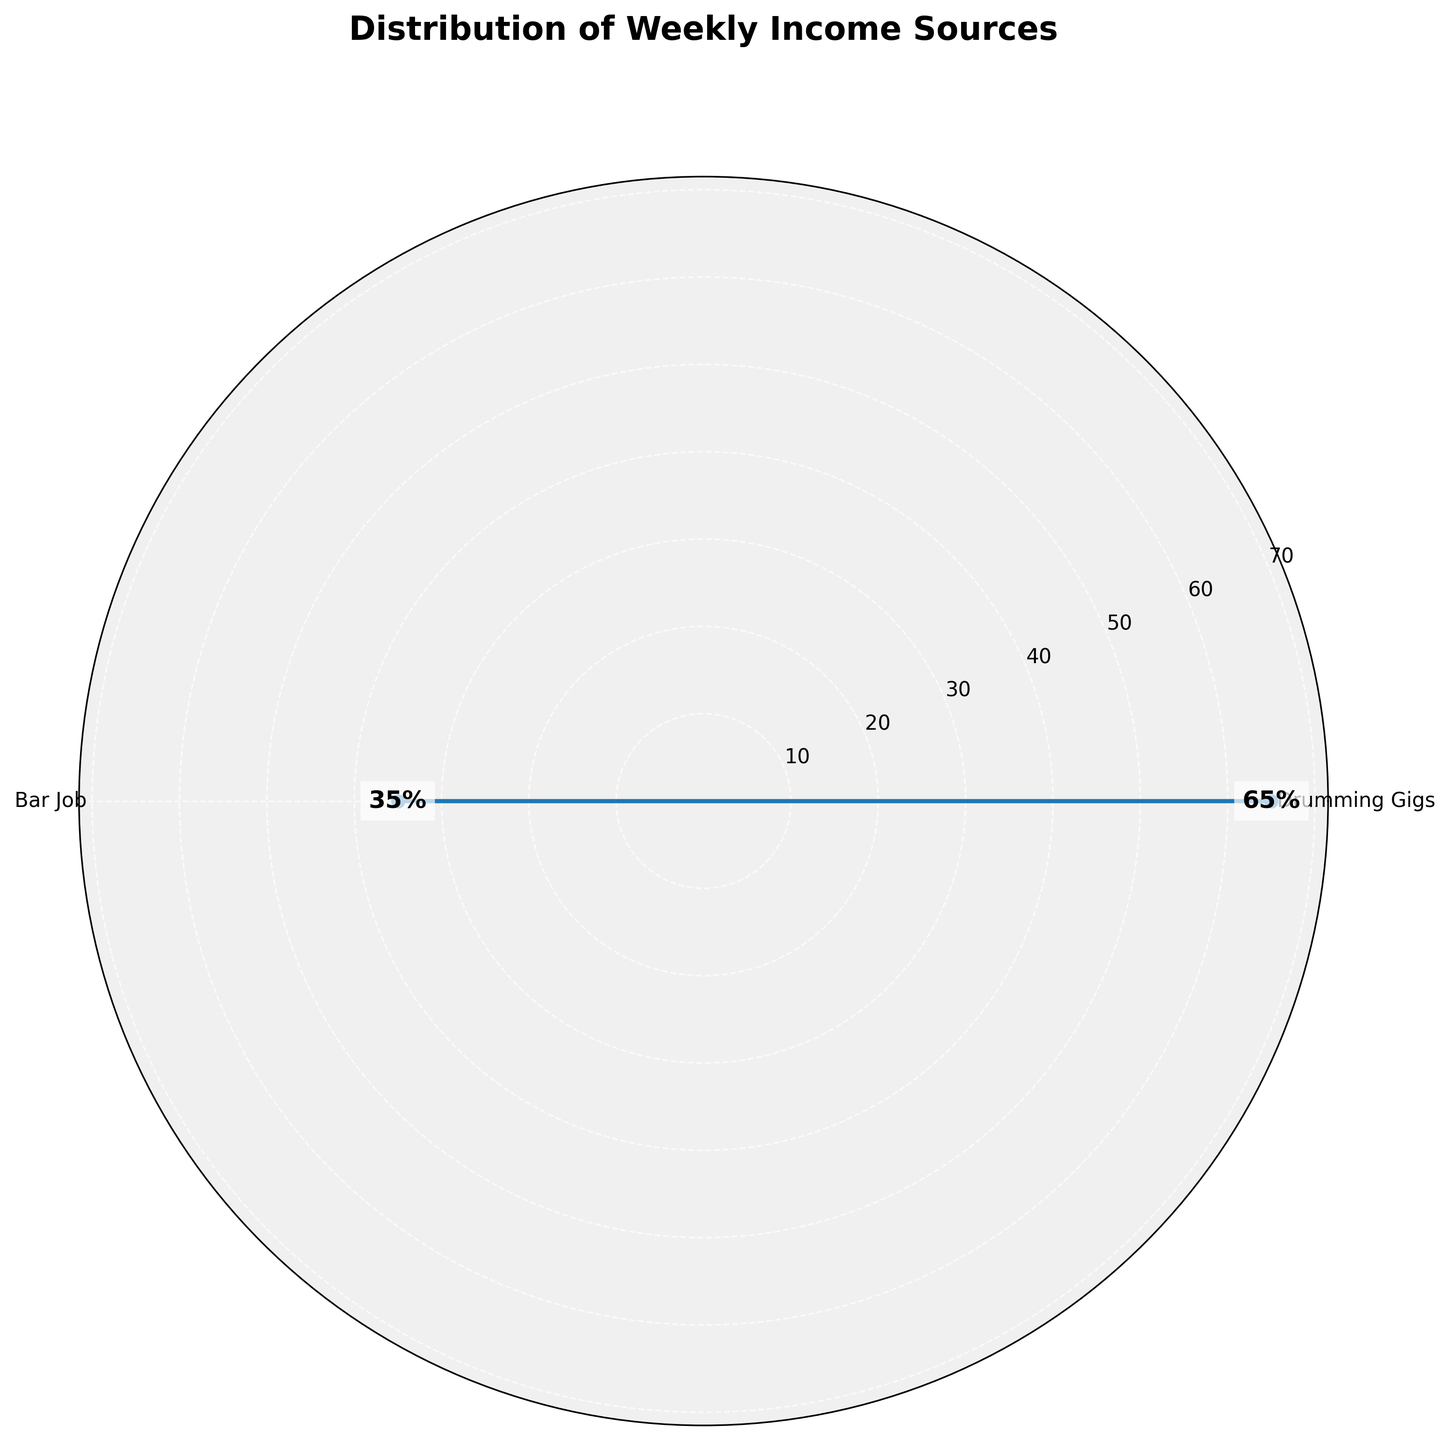What's the title of the figure? The title is located at the top of the figure. It summarizes the main topic of the chart.
Answer: Distribution of Weekly Income Sources How many income sources are represented in the figure? By counting the labeled ticks around the circular axis, we can see there are two categories labeled.
Answer: 2 What percentage does the bar job contribute to the weekly income? Examine the text labels indicating percentages near each corresponding data point on the chart.
Answer: 35% What is the difference in percentage between drumming gigs and the bar job? Subtract the percentage of the bar job (35%) from the percentage of drumming gigs (65%).
Answer: 30% Which income source has a higher percentage? Compare the percentages labeled near each data point. The category with the higher percentage has more contribution.
Answer: Drumming Gigs How are the values represented on the radial axis? Each radial line extending out from the center of the chart corresponds to a specific percentage value. The values are marked appropriately along each radial.
Answer: Percentages What is the visual appearance of the plot? Observe the style and elements in the figure including color fills, line types, and background.
Answer: The plot uses filled areas and solid lines with a light gray background Are the categories evenly spaced around the circular axis? Check if the labels are symmetrically distributed around the circle. Given there are two categories, they should be spaced equally.
Answer: Yes What can you infer about the relative contribution of the two income sources? By comparing the values, it can be inferred that one source contributes significantly more to the overall income than the other.
Answer: Drumming gigs contribute significantly more than the bar job 